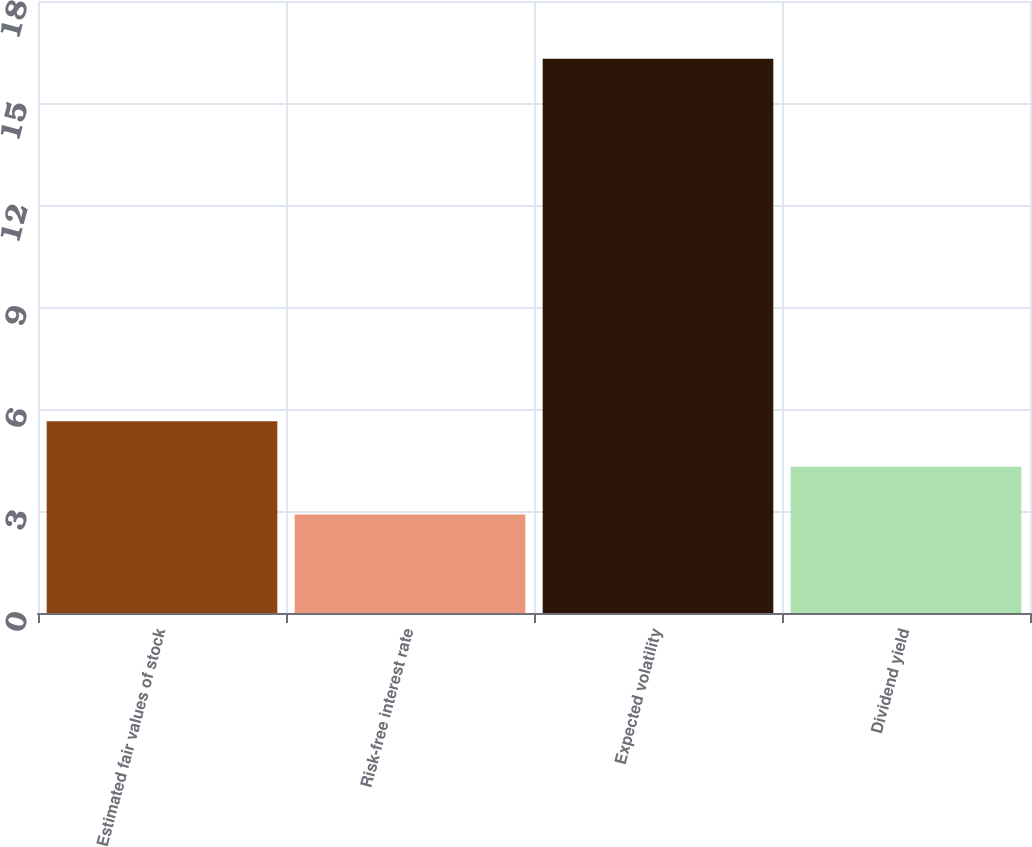Convert chart to OTSL. <chart><loc_0><loc_0><loc_500><loc_500><bar_chart><fcel>Estimated fair values of stock<fcel>Risk-free interest rate<fcel>Expected volatility<fcel>Dividend yield<nl><fcel>5.64<fcel>2.9<fcel>16.3<fcel>4.3<nl></chart> 